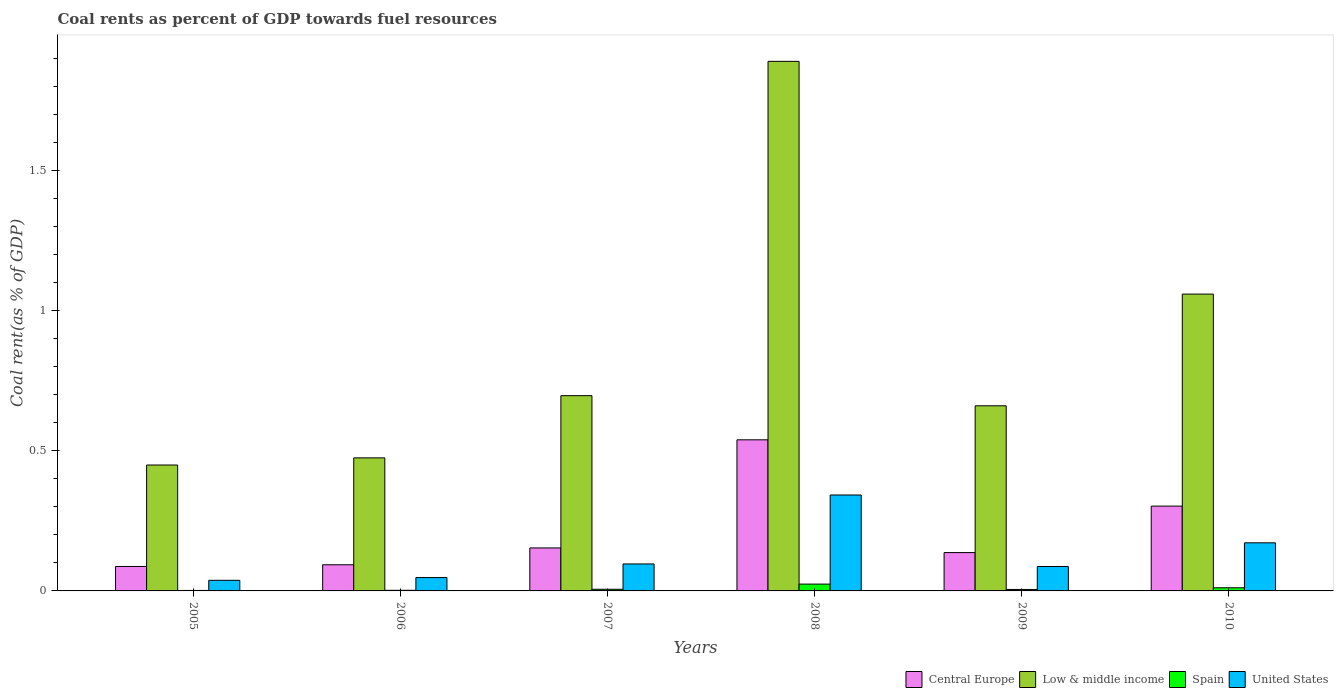How many groups of bars are there?
Keep it short and to the point. 6. Are the number of bars per tick equal to the number of legend labels?
Ensure brevity in your answer.  Yes. Are the number of bars on each tick of the X-axis equal?
Ensure brevity in your answer.  Yes. How many bars are there on the 3rd tick from the left?
Provide a short and direct response. 4. What is the coal rent in United States in 2007?
Provide a succinct answer. 0.1. Across all years, what is the maximum coal rent in United States?
Give a very brief answer. 0.34. Across all years, what is the minimum coal rent in Central Europe?
Your answer should be very brief. 0.09. In which year was the coal rent in Central Europe maximum?
Keep it short and to the point. 2008. What is the total coal rent in United States in the graph?
Provide a succinct answer. 0.78. What is the difference between the coal rent in United States in 2005 and that in 2007?
Keep it short and to the point. -0.06. What is the difference between the coal rent in Central Europe in 2010 and the coal rent in United States in 2005?
Make the answer very short. 0.26. What is the average coal rent in Low & middle income per year?
Make the answer very short. 0.87. In the year 2006, what is the difference between the coal rent in Central Europe and coal rent in Spain?
Provide a short and direct response. 0.09. What is the ratio of the coal rent in United States in 2006 to that in 2009?
Keep it short and to the point. 0.55. What is the difference between the highest and the second highest coal rent in Low & middle income?
Provide a short and direct response. 0.83. What is the difference between the highest and the lowest coal rent in Spain?
Keep it short and to the point. 0.02. In how many years, is the coal rent in Central Europe greater than the average coal rent in Central Europe taken over all years?
Your answer should be compact. 2. Is it the case that in every year, the sum of the coal rent in United States and coal rent in Central Europe is greater than the sum of coal rent in Low & middle income and coal rent in Spain?
Provide a short and direct response. Yes. What does the 2nd bar from the right in 2006 represents?
Your response must be concise. Spain. How many bars are there?
Keep it short and to the point. 24. What is the difference between two consecutive major ticks on the Y-axis?
Your answer should be very brief. 0.5. Are the values on the major ticks of Y-axis written in scientific E-notation?
Provide a short and direct response. No. Where does the legend appear in the graph?
Keep it short and to the point. Bottom right. What is the title of the graph?
Offer a very short reply. Coal rents as percent of GDP towards fuel resources. What is the label or title of the Y-axis?
Your answer should be compact. Coal rent(as % of GDP). What is the Coal rent(as % of GDP) in Central Europe in 2005?
Offer a terse response. 0.09. What is the Coal rent(as % of GDP) of Low & middle income in 2005?
Your response must be concise. 0.45. What is the Coal rent(as % of GDP) in Spain in 2005?
Give a very brief answer. 0. What is the Coal rent(as % of GDP) of United States in 2005?
Offer a terse response. 0.04. What is the Coal rent(as % of GDP) in Central Europe in 2006?
Provide a succinct answer. 0.09. What is the Coal rent(as % of GDP) of Low & middle income in 2006?
Provide a short and direct response. 0.47. What is the Coal rent(as % of GDP) in Spain in 2006?
Make the answer very short. 0. What is the Coal rent(as % of GDP) of United States in 2006?
Your answer should be very brief. 0.05. What is the Coal rent(as % of GDP) in Central Europe in 2007?
Your answer should be compact. 0.15. What is the Coal rent(as % of GDP) of Low & middle income in 2007?
Offer a terse response. 0.7. What is the Coal rent(as % of GDP) in Spain in 2007?
Make the answer very short. 0.01. What is the Coal rent(as % of GDP) in United States in 2007?
Offer a terse response. 0.1. What is the Coal rent(as % of GDP) of Central Europe in 2008?
Your answer should be very brief. 0.54. What is the Coal rent(as % of GDP) of Low & middle income in 2008?
Make the answer very short. 1.89. What is the Coal rent(as % of GDP) of Spain in 2008?
Offer a terse response. 0.02. What is the Coal rent(as % of GDP) of United States in 2008?
Your response must be concise. 0.34. What is the Coal rent(as % of GDP) in Central Europe in 2009?
Your answer should be compact. 0.14. What is the Coal rent(as % of GDP) of Low & middle income in 2009?
Make the answer very short. 0.66. What is the Coal rent(as % of GDP) in Spain in 2009?
Keep it short and to the point. 0.01. What is the Coal rent(as % of GDP) in United States in 2009?
Provide a short and direct response. 0.09. What is the Coal rent(as % of GDP) in Central Europe in 2010?
Make the answer very short. 0.3. What is the Coal rent(as % of GDP) in Low & middle income in 2010?
Your response must be concise. 1.06. What is the Coal rent(as % of GDP) in Spain in 2010?
Provide a succinct answer. 0.01. What is the Coal rent(as % of GDP) in United States in 2010?
Ensure brevity in your answer.  0.17. Across all years, what is the maximum Coal rent(as % of GDP) in Central Europe?
Keep it short and to the point. 0.54. Across all years, what is the maximum Coal rent(as % of GDP) of Low & middle income?
Offer a terse response. 1.89. Across all years, what is the maximum Coal rent(as % of GDP) in Spain?
Keep it short and to the point. 0.02. Across all years, what is the maximum Coal rent(as % of GDP) of United States?
Your answer should be very brief. 0.34. Across all years, what is the minimum Coal rent(as % of GDP) of Central Europe?
Provide a succinct answer. 0.09. Across all years, what is the minimum Coal rent(as % of GDP) of Low & middle income?
Offer a terse response. 0.45. Across all years, what is the minimum Coal rent(as % of GDP) of Spain?
Offer a terse response. 0. Across all years, what is the minimum Coal rent(as % of GDP) in United States?
Offer a terse response. 0.04. What is the total Coal rent(as % of GDP) of Central Europe in the graph?
Your answer should be very brief. 1.31. What is the total Coal rent(as % of GDP) of Low & middle income in the graph?
Ensure brevity in your answer.  5.23. What is the total Coal rent(as % of GDP) of Spain in the graph?
Provide a short and direct response. 0.05. What is the total Coal rent(as % of GDP) of United States in the graph?
Your answer should be very brief. 0.78. What is the difference between the Coal rent(as % of GDP) of Central Europe in 2005 and that in 2006?
Provide a short and direct response. -0.01. What is the difference between the Coal rent(as % of GDP) in Low & middle income in 2005 and that in 2006?
Your response must be concise. -0.03. What is the difference between the Coal rent(as % of GDP) of Spain in 2005 and that in 2006?
Offer a terse response. -0. What is the difference between the Coal rent(as % of GDP) of United States in 2005 and that in 2006?
Your response must be concise. -0.01. What is the difference between the Coal rent(as % of GDP) of Central Europe in 2005 and that in 2007?
Provide a short and direct response. -0.07. What is the difference between the Coal rent(as % of GDP) of Low & middle income in 2005 and that in 2007?
Give a very brief answer. -0.25. What is the difference between the Coal rent(as % of GDP) of Spain in 2005 and that in 2007?
Provide a short and direct response. -0. What is the difference between the Coal rent(as % of GDP) of United States in 2005 and that in 2007?
Provide a succinct answer. -0.06. What is the difference between the Coal rent(as % of GDP) in Central Europe in 2005 and that in 2008?
Provide a short and direct response. -0.45. What is the difference between the Coal rent(as % of GDP) of Low & middle income in 2005 and that in 2008?
Your answer should be very brief. -1.44. What is the difference between the Coal rent(as % of GDP) in Spain in 2005 and that in 2008?
Your answer should be very brief. -0.02. What is the difference between the Coal rent(as % of GDP) in United States in 2005 and that in 2008?
Your answer should be compact. -0.3. What is the difference between the Coal rent(as % of GDP) of Central Europe in 2005 and that in 2009?
Give a very brief answer. -0.05. What is the difference between the Coal rent(as % of GDP) in Low & middle income in 2005 and that in 2009?
Offer a very short reply. -0.21. What is the difference between the Coal rent(as % of GDP) of Spain in 2005 and that in 2009?
Provide a short and direct response. -0. What is the difference between the Coal rent(as % of GDP) in United States in 2005 and that in 2009?
Provide a succinct answer. -0.05. What is the difference between the Coal rent(as % of GDP) of Central Europe in 2005 and that in 2010?
Your response must be concise. -0.22. What is the difference between the Coal rent(as % of GDP) in Low & middle income in 2005 and that in 2010?
Your answer should be very brief. -0.61. What is the difference between the Coal rent(as % of GDP) of Spain in 2005 and that in 2010?
Offer a terse response. -0.01. What is the difference between the Coal rent(as % of GDP) in United States in 2005 and that in 2010?
Keep it short and to the point. -0.13. What is the difference between the Coal rent(as % of GDP) in Central Europe in 2006 and that in 2007?
Provide a succinct answer. -0.06. What is the difference between the Coal rent(as % of GDP) of Low & middle income in 2006 and that in 2007?
Make the answer very short. -0.22. What is the difference between the Coal rent(as % of GDP) in Spain in 2006 and that in 2007?
Your answer should be very brief. -0. What is the difference between the Coal rent(as % of GDP) of United States in 2006 and that in 2007?
Keep it short and to the point. -0.05. What is the difference between the Coal rent(as % of GDP) of Central Europe in 2006 and that in 2008?
Offer a terse response. -0.45. What is the difference between the Coal rent(as % of GDP) in Low & middle income in 2006 and that in 2008?
Your answer should be compact. -1.41. What is the difference between the Coal rent(as % of GDP) of Spain in 2006 and that in 2008?
Ensure brevity in your answer.  -0.02. What is the difference between the Coal rent(as % of GDP) in United States in 2006 and that in 2008?
Make the answer very short. -0.29. What is the difference between the Coal rent(as % of GDP) in Central Europe in 2006 and that in 2009?
Your response must be concise. -0.04. What is the difference between the Coal rent(as % of GDP) of Low & middle income in 2006 and that in 2009?
Your response must be concise. -0.19. What is the difference between the Coal rent(as % of GDP) in Spain in 2006 and that in 2009?
Offer a very short reply. -0. What is the difference between the Coal rent(as % of GDP) of United States in 2006 and that in 2009?
Make the answer very short. -0.04. What is the difference between the Coal rent(as % of GDP) of Central Europe in 2006 and that in 2010?
Your answer should be very brief. -0.21. What is the difference between the Coal rent(as % of GDP) of Low & middle income in 2006 and that in 2010?
Your answer should be compact. -0.58. What is the difference between the Coal rent(as % of GDP) in Spain in 2006 and that in 2010?
Your answer should be very brief. -0.01. What is the difference between the Coal rent(as % of GDP) of United States in 2006 and that in 2010?
Provide a succinct answer. -0.12. What is the difference between the Coal rent(as % of GDP) in Central Europe in 2007 and that in 2008?
Make the answer very short. -0.39. What is the difference between the Coal rent(as % of GDP) of Low & middle income in 2007 and that in 2008?
Give a very brief answer. -1.19. What is the difference between the Coal rent(as % of GDP) of Spain in 2007 and that in 2008?
Provide a short and direct response. -0.02. What is the difference between the Coal rent(as % of GDP) of United States in 2007 and that in 2008?
Ensure brevity in your answer.  -0.25. What is the difference between the Coal rent(as % of GDP) in Central Europe in 2007 and that in 2009?
Your response must be concise. 0.02. What is the difference between the Coal rent(as % of GDP) of Low & middle income in 2007 and that in 2009?
Give a very brief answer. 0.04. What is the difference between the Coal rent(as % of GDP) of Spain in 2007 and that in 2009?
Keep it short and to the point. 0. What is the difference between the Coal rent(as % of GDP) of United States in 2007 and that in 2009?
Keep it short and to the point. 0.01. What is the difference between the Coal rent(as % of GDP) in Central Europe in 2007 and that in 2010?
Make the answer very short. -0.15. What is the difference between the Coal rent(as % of GDP) of Low & middle income in 2007 and that in 2010?
Your response must be concise. -0.36. What is the difference between the Coal rent(as % of GDP) of Spain in 2007 and that in 2010?
Provide a succinct answer. -0.01. What is the difference between the Coal rent(as % of GDP) in United States in 2007 and that in 2010?
Your answer should be compact. -0.08. What is the difference between the Coal rent(as % of GDP) of Central Europe in 2008 and that in 2009?
Offer a terse response. 0.4. What is the difference between the Coal rent(as % of GDP) in Low & middle income in 2008 and that in 2009?
Offer a very short reply. 1.23. What is the difference between the Coal rent(as % of GDP) of Spain in 2008 and that in 2009?
Make the answer very short. 0.02. What is the difference between the Coal rent(as % of GDP) of United States in 2008 and that in 2009?
Give a very brief answer. 0.26. What is the difference between the Coal rent(as % of GDP) of Central Europe in 2008 and that in 2010?
Offer a very short reply. 0.24. What is the difference between the Coal rent(as % of GDP) in Low & middle income in 2008 and that in 2010?
Your response must be concise. 0.83. What is the difference between the Coal rent(as % of GDP) in Spain in 2008 and that in 2010?
Your answer should be compact. 0.01. What is the difference between the Coal rent(as % of GDP) in United States in 2008 and that in 2010?
Give a very brief answer. 0.17. What is the difference between the Coal rent(as % of GDP) of Central Europe in 2009 and that in 2010?
Offer a terse response. -0.17. What is the difference between the Coal rent(as % of GDP) of Low & middle income in 2009 and that in 2010?
Provide a short and direct response. -0.4. What is the difference between the Coal rent(as % of GDP) in Spain in 2009 and that in 2010?
Ensure brevity in your answer.  -0.01. What is the difference between the Coal rent(as % of GDP) in United States in 2009 and that in 2010?
Offer a terse response. -0.08. What is the difference between the Coal rent(as % of GDP) in Central Europe in 2005 and the Coal rent(as % of GDP) in Low & middle income in 2006?
Offer a terse response. -0.39. What is the difference between the Coal rent(as % of GDP) in Central Europe in 2005 and the Coal rent(as % of GDP) in Spain in 2006?
Provide a succinct answer. 0.09. What is the difference between the Coal rent(as % of GDP) of Central Europe in 2005 and the Coal rent(as % of GDP) of United States in 2006?
Offer a terse response. 0.04. What is the difference between the Coal rent(as % of GDP) in Low & middle income in 2005 and the Coal rent(as % of GDP) in Spain in 2006?
Your response must be concise. 0.45. What is the difference between the Coal rent(as % of GDP) in Low & middle income in 2005 and the Coal rent(as % of GDP) in United States in 2006?
Offer a very short reply. 0.4. What is the difference between the Coal rent(as % of GDP) of Spain in 2005 and the Coal rent(as % of GDP) of United States in 2006?
Provide a succinct answer. -0.05. What is the difference between the Coal rent(as % of GDP) of Central Europe in 2005 and the Coal rent(as % of GDP) of Low & middle income in 2007?
Your response must be concise. -0.61. What is the difference between the Coal rent(as % of GDP) in Central Europe in 2005 and the Coal rent(as % of GDP) in Spain in 2007?
Make the answer very short. 0.08. What is the difference between the Coal rent(as % of GDP) in Central Europe in 2005 and the Coal rent(as % of GDP) in United States in 2007?
Your answer should be very brief. -0.01. What is the difference between the Coal rent(as % of GDP) in Low & middle income in 2005 and the Coal rent(as % of GDP) in Spain in 2007?
Provide a short and direct response. 0.44. What is the difference between the Coal rent(as % of GDP) in Low & middle income in 2005 and the Coal rent(as % of GDP) in United States in 2007?
Offer a terse response. 0.35. What is the difference between the Coal rent(as % of GDP) in Spain in 2005 and the Coal rent(as % of GDP) in United States in 2007?
Give a very brief answer. -0.09. What is the difference between the Coal rent(as % of GDP) of Central Europe in 2005 and the Coal rent(as % of GDP) of Low & middle income in 2008?
Offer a very short reply. -1.8. What is the difference between the Coal rent(as % of GDP) of Central Europe in 2005 and the Coal rent(as % of GDP) of Spain in 2008?
Ensure brevity in your answer.  0.06. What is the difference between the Coal rent(as % of GDP) of Central Europe in 2005 and the Coal rent(as % of GDP) of United States in 2008?
Make the answer very short. -0.25. What is the difference between the Coal rent(as % of GDP) in Low & middle income in 2005 and the Coal rent(as % of GDP) in Spain in 2008?
Ensure brevity in your answer.  0.42. What is the difference between the Coal rent(as % of GDP) in Low & middle income in 2005 and the Coal rent(as % of GDP) in United States in 2008?
Give a very brief answer. 0.11. What is the difference between the Coal rent(as % of GDP) in Spain in 2005 and the Coal rent(as % of GDP) in United States in 2008?
Offer a very short reply. -0.34. What is the difference between the Coal rent(as % of GDP) of Central Europe in 2005 and the Coal rent(as % of GDP) of Low & middle income in 2009?
Your answer should be very brief. -0.57. What is the difference between the Coal rent(as % of GDP) of Central Europe in 2005 and the Coal rent(as % of GDP) of Spain in 2009?
Keep it short and to the point. 0.08. What is the difference between the Coal rent(as % of GDP) of Central Europe in 2005 and the Coal rent(as % of GDP) of United States in 2009?
Your answer should be compact. 0. What is the difference between the Coal rent(as % of GDP) of Low & middle income in 2005 and the Coal rent(as % of GDP) of Spain in 2009?
Your answer should be compact. 0.44. What is the difference between the Coal rent(as % of GDP) of Low & middle income in 2005 and the Coal rent(as % of GDP) of United States in 2009?
Keep it short and to the point. 0.36. What is the difference between the Coal rent(as % of GDP) of Spain in 2005 and the Coal rent(as % of GDP) of United States in 2009?
Give a very brief answer. -0.09. What is the difference between the Coal rent(as % of GDP) of Central Europe in 2005 and the Coal rent(as % of GDP) of Low & middle income in 2010?
Your answer should be very brief. -0.97. What is the difference between the Coal rent(as % of GDP) in Central Europe in 2005 and the Coal rent(as % of GDP) in Spain in 2010?
Provide a succinct answer. 0.08. What is the difference between the Coal rent(as % of GDP) in Central Europe in 2005 and the Coal rent(as % of GDP) in United States in 2010?
Offer a terse response. -0.08. What is the difference between the Coal rent(as % of GDP) in Low & middle income in 2005 and the Coal rent(as % of GDP) in Spain in 2010?
Your answer should be very brief. 0.44. What is the difference between the Coal rent(as % of GDP) in Low & middle income in 2005 and the Coal rent(as % of GDP) in United States in 2010?
Your answer should be compact. 0.28. What is the difference between the Coal rent(as % of GDP) of Spain in 2005 and the Coal rent(as % of GDP) of United States in 2010?
Give a very brief answer. -0.17. What is the difference between the Coal rent(as % of GDP) in Central Europe in 2006 and the Coal rent(as % of GDP) in Low & middle income in 2007?
Your answer should be compact. -0.6. What is the difference between the Coal rent(as % of GDP) in Central Europe in 2006 and the Coal rent(as % of GDP) in Spain in 2007?
Offer a terse response. 0.09. What is the difference between the Coal rent(as % of GDP) in Central Europe in 2006 and the Coal rent(as % of GDP) in United States in 2007?
Your answer should be compact. -0. What is the difference between the Coal rent(as % of GDP) in Low & middle income in 2006 and the Coal rent(as % of GDP) in Spain in 2007?
Provide a succinct answer. 0.47. What is the difference between the Coal rent(as % of GDP) of Low & middle income in 2006 and the Coal rent(as % of GDP) of United States in 2007?
Offer a very short reply. 0.38. What is the difference between the Coal rent(as % of GDP) in Spain in 2006 and the Coal rent(as % of GDP) in United States in 2007?
Ensure brevity in your answer.  -0.09. What is the difference between the Coal rent(as % of GDP) in Central Europe in 2006 and the Coal rent(as % of GDP) in Low & middle income in 2008?
Provide a short and direct response. -1.8. What is the difference between the Coal rent(as % of GDP) of Central Europe in 2006 and the Coal rent(as % of GDP) of Spain in 2008?
Your response must be concise. 0.07. What is the difference between the Coal rent(as % of GDP) of Central Europe in 2006 and the Coal rent(as % of GDP) of United States in 2008?
Offer a very short reply. -0.25. What is the difference between the Coal rent(as % of GDP) in Low & middle income in 2006 and the Coal rent(as % of GDP) in Spain in 2008?
Keep it short and to the point. 0.45. What is the difference between the Coal rent(as % of GDP) in Low & middle income in 2006 and the Coal rent(as % of GDP) in United States in 2008?
Ensure brevity in your answer.  0.13. What is the difference between the Coal rent(as % of GDP) of Spain in 2006 and the Coal rent(as % of GDP) of United States in 2008?
Offer a terse response. -0.34. What is the difference between the Coal rent(as % of GDP) of Central Europe in 2006 and the Coal rent(as % of GDP) of Low & middle income in 2009?
Give a very brief answer. -0.57. What is the difference between the Coal rent(as % of GDP) of Central Europe in 2006 and the Coal rent(as % of GDP) of Spain in 2009?
Make the answer very short. 0.09. What is the difference between the Coal rent(as % of GDP) of Central Europe in 2006 and the Coal rent(as % of GDP) of United States in 2009?
Provide a short and direct response. 0.01. What is the difference between the Coal rent(as % of GDP) in Low & middle income in 2006 and the Coal rent(as % of GDP) in Spain in 2009?
Keep it short and to the point. 0.47. What is the difference between the Coal rent(as % of GDP) in Low & middle income in 2006 and the Coal rent(as % of GDP) in United States in 2009?
Ensure brevity in your answer.  0.39. What is the difference between the Coal rent(as % of GDP) of Spain in 2006 and the Coal rent(as % of GDP) of United States in 2009?
Keep it short and to the point. -0.08. What is the difference between the Coal rent(as % of GDP) of Central Europe in 2006 and the Coal rent(as % of GDP) of Low & middle income in 2010?
Ensure brevity in your answer.  -0.97. What is the difference between the Coal rent(as % of GDP) of Central Europe in 2006 and the Coal rent(as % of GDP) of Spain in 2010?
Offer a terse response. 0.08. What is the difference between the Coal rent(as % of GDP) in Central Europe in 2006 and the Coal rent(as % of GDP) in United States in 2010?
Keep it short and to the point. -0.08. What is the difference between the Coal rent(as % of GDP) of Low & middle income in 2006 and the Coal rent(as % of GDP) of Spain in 2010?
Your response must be concise. 0.46. What is the difference between the Coal rent(as % of GDP) in Low & middle income in 2006 and the Coal rent(as % of GDP) in United States in 2010?
Make the answer very short. 0.3. What is the difference between the Coal rent(as % of GDP) in Spain in 2006 and the Coal rent(as % of GDP) in United States in 2010?
Make the answer very short. -0.17. What is the difference between the Coal rent(as % of GDP) in Central Europe in 2007 and the Coal rent(as % of GDP) in Low & middle income in 2008?
Provide a succinct answer. -1.74. What is the difference between the Coal rent(as % of GDP) in Central Europe in 2007 and the Coal rent(as % of GDP) in Spain in 2008?
Keep it short and to the point. 0.13. What is the difference between the Coal rent(as % of GDP) in Central Europe in 2007 and the Coal rent(as % of GDP) in United States in 2008?
Your answer should be compact. -0.19. What is the difference between the Coal rent(as % of GDP) of Low & middle income in 2007 and the Coal rent(as % of GDP) of Spain in 2008?
Ensure brevity in your answer.  0.67. What is the difference between the Coal rent(as % of GDP) of Low & middle income in 2007 and the Coal rent(as % of GDP) of United States in 2008?
Provide a short and direct response. 0.35. What is the difference between the Coal rent(as % of GDP) of Spain in 2007 and the Coal rent(as % of GDP) of United States in 2008?
Keep it short and to the point. -0.34. What is the difference between the Coal rent(as % of GDP) of Central Europe in 2007 and the Coal rent(as % of GDP) of Low & middle income in 2009?
Keep it short and to the point. -0.51. What is the difference between the Coal rent(as % of GDP) of Central Europe in 2007 and the Coal rent(as % of GDP) of Spain in 2009?
Offer a terse response. 0.15. What is the difference between the Coal rent(as % of GDP) in Central Europe in 2007 and the Coal rent(as % of GDP) in United States in 2009?
Your answer should be compact. 0.07. What is the difference between the Coal rent(as % of GDP) in Low & middle income in 2007 and the Coal rent(as % of GDP) in Spain in 2009?
Your response must be concise. 0.69. What is the difference between the Coal rent(as % of GDP) of Low & middle income in 2007 and the Coal rent(as % of GDP) of United States in 2009?
Make the answer very short. 0.61. What is the difference between the Coal rent(as % of GDP) in Spain in 2007 and the Coal rent(as % of GDP) in United States in 2009?
Keep it short and to the point. -0.08. What is the difference between the Coal rent(as % of GDP) of Central Europe in 2007 and the Coal rent(as % of GDP) of Low & middle income in 2010?
Provide a succinct answer. -0.91. What is the difference between the Coal rent(as % of GDP) of Central Europe in 2007 and the Coal rent(as % of GDP) of Spain in 2010?
Your response must be concise. 0.14. What is the difference between the Coal rent(as % of GDP) of Central Europe in 2007 and the Coal rent(as % of GDP) of United States in 2010?
Provide a succinct answer. -0.02. What is the difference between the Coal rent(as % of GDP) of Low & middle income in 2007 and the Coal rent(as % of GDP) of Spain in 2010?
Ensure brevity in your answer.  0.69. What is the difference between the Coal rent(as % of GDP) of Low & middle income in 2007 and the Coal rent(as % of GDP) of United States in 2010?
Offer a terse response. 0.52. What is the difference between the Coal rent(as % of GDP) in Spain in 2007 and the Coal rent(as % of GDP) in United States in 2010?
Keep it short and to the point. -0.17. What is the difference between the Coal rent(as % of GDP) in Central Europe in 2008 and the Coal rent(as % of GDP) in Low & middle income in 2009?
Offer a terse response. -0.12. What is the difference between the Coal rent(as % of GDP) in Central Europe in 2008 and the Coal rent(as % of GDP) in Spain in 2009?
Your answer should be very brief. 0.53. What is the difference between the Coal rent(as % of GDP) of Central Europe in 2008 and the Coal rent(as % of GDP) of United States in 2009?
Your answer should be very brief. 0.45. What is the difference between the Coal rent(as % of GDP) of Low & middle income in 2008 and the Coal rent(as % of GDP) of Spain in 2009?
Make the answer very short. 1.88. What is the difference between the Coal rent(as % of GDP) of Low & middle income in 2008 and the Coal rent(as % of GDP) of United States in 2009?
Provide a short and direct response. 1.8. What is the difference between the Coal rent(as % of GDP) in Spain in 2008 and the Coal rent(as % of GDP) in United States in 2009?
Your answer should be compact. -0.06. What is the difference between the Coal rent(as % of GDP) of Central Europe in 2008 and the Coal rent(as % of GDP) of Low & middle income in 2010?
Your answer should be very brief. -0.52. What is the difference between the Coal rent(as % of GDP) of Central Europe in 2008 and the Coal rent(as % of GDP) of Spain in 2010?
Offer a terse response. 0.53. What is the difference between the Coal rent(as % of GDP) in Central Europe in 2008 and the Coal rent(as % of GDP) in United States in 2010?
Provide a succinct answer. 0.37. What is the difference between the Coal rent(as % of GDP) of Low & middle income in 2008 and the Coal rent(as % of GDP) of Spain in 2010?
Ensure brevity in your answer.  1.88. What is the difference between the Coal rent(as % of GDP) of Low & middle income in 2008 and the Coal rent(as % of GDP) of United States in 2010?
Offer a very short reply. 1.72. What is the difference between the Coal rent(as % of GDP) of Spain in 2008 and the Coal rent(as % of GDP) of United States in 2010?
Your answer should be very brief. -0.15. What is the difference between the Coal rent(as % of GDP) of Central Europe in 2009 and the Coal rent(as % of GDP) of Low & middle income in 2010?
Provide a succinct answer. -0.92. What is the difference between the Coal rent(as % of GDP) of Central Europe in 2009 and the Coal rent(as % of GDP) of Spain in 2010?
Make the answer very short. 0.13. What is the difference between the Coal rent(as % of GDP) of Central Europe in 2009 and the Coal rent(as % of GDP) of United States in 2010?
Your answer should be compact. -0.03. What is the difference between the Coal rent(as % of GDP) of Low & middle income in 2009 and the Coal rent(as % of GDP) of Spain in 2010?
Give a very brief answer. 0.65. What is the difference between the Coal rent(as % of GDP) of Low & middle income in 2009 and the Coal rent(as % of GDP) of United States in 2010?
Give a very brief answer. 0.49. What is the difference between the Coal rent(as % of GDP) of Spain in 2009 and the Coal rent(as % of GDP) of United States in 2010?
Your response must be concise. -0.17. What is the average Coal rent(as % of GDP) in Central Europe per year?
Provide a short and direct response. 0.22. What is the average Coal rent(as % of GDP) in Low & middle income per year?
Your answer should be very brief. 0.87. What is the average Coal rent(as % of GDP) in Spain per year?
Your answer should be very brief. 0.01. What is the average Coal rent(as % of GDP) of United States per year?
Ensure brevity in your answer.  0.13. In the year 2005, what is the difference between the Coal rent(as % of GDP) in Central Europe and Coal rent(as % of GDP) in Low & middle income?
Keep it short and to the point. -0.36. In the year 2005, what is the difference between the Coal rent(as % of GDP) of Central Europe and Coal rent(as % of GDP) of Spain?
Make the answer very short. 0.09. In the year 2005, what is the difference between the Coal rent(as % of GDP) in Central Europe and Coal rent(as % of GDP) in United States?
Provide a succinct answer. 0.05. In the year 2005, what is the difference between the Coal rent(as % of GDP) of Low & middle income and Coal rent(as % of GDP) of Spain?
Keep it short and to the point. 0.45. In the year 2005, what is the difference between the Coal rent(as % of GDP) of Low & middle income and Coal rent(as % of GDP) of United States?
Offer a terse response. 0.41. In the year 2005, what is the difference between the Coal rent(as % of GDP) in Spain and Coal rent(as % of GDP) in United States?
Ensure brevity in your answer.  -0.04. In the year 2006, what is the difference between the Coal rent(as % of GDP) of Central Europe and Coal rent(as % of GDP) of Low & middle income?
Provide a short and direct response. -0.38. In the year 2006, what is the difference between the Coal rent(as % of GDP) in Central Europe and Coal rent(as % of GDP) in Spain?
Ensure brevity in your answer.  0.09. In the year 2006, what is the difference between the Coal rent(as % of GDP) in Central Europe and Coal rent(as % of GDP) in United States?
Ensure brevity in your answer.  0.05. In the year 2006, what is the difference between the Coal rent(as % of GDP) in Low & middle income and Coal rent(as % of GDP) in Spain?
Make the answer very short. 0.47. In the year 2006, what is the difference between the Coal rent(as % of GDP) of Low & middle income and Coal rent(as % of GDP) of United States?
Give a very brief answer. 0.43. In the year 2006, what is the difference between the Coal rent(as % of GDP) of Spain and Coal rent(as % of GDP) of United States?
Ensure brevity in your answer.  -0.05. In the year 2007, what is the difference between the Coal rent(as % of GDP) of Central Europe and Coal rent(as % of GDP) of Low & middle income?
Your response must be concise. -0.54. In the year 2007, what is the difference between the Coal rent(as % of GDP) of Central Europe and Coal rent(as % of GDP) of Spain?
Ensure brevity in your answer.  0.15. In the year 2007, what is the difference between the Coal rent(as % of GDP) in Central Europe and Coal rent(as % of GDP) in United States?
Keep it short and to the point. 0.06. In the year 2007, what is the difference between the Coal rent(as % of GDP) of Low & middle income and Coal rent(as % of GDP) of Spain?
Offer a very short reply. 0.69. In the year 2007, what is the difference between the Coal rent(as % of GDP) in Low & middle income and Coal rent(as % of GDP) in United States?
Offer a terse response. 0.6. In the year 2007, what is the difference between the Coal rent(as % of GDP) of Spain and Coal rent(as % of GDP) of United States?
Give a very brief answer. -0.09. In the year 2008, what is the difference between the Coal rent(as % of GDP) of Central Europe and Coal rent(as % of GDP) of Low & middle income?
Make the answer very short. -1.35. In the year 2008, what is the difference between the Coal rent(as % of GDP) in Central Europe and Coal rent(as % of GDP) in Spain?
Provide a succinct answer. 0.51. In the year 2008, what is the difference between the Coal rent(as % of GDP) of Central Europe and Coal rent(as % of GDP) of United States?
Give a very brief answer. 0.2. In the year 2008, what is the difference between the Coal rent(as % of GDP) in Low & middle income and Coal rent(as % of GDP) in Spain?
Ensure brevity in your answer.  1.86. In the year 2008, what is the difference between the Coal rent(as % of GDP) of Low & middle income and Coal rent(as % of GDP) of United States?
Your answer should be very brief. 1.55. In the year 2008, what is the difference between the Coal rent(as % of GDP) of Spain and Coal rent(as % of GDP) of United States?
Your answer should be compact. -0.32. In the year 2009, what is the difference between the Coal rent(as % of GDP) of Central Europe and Coal rent(as % of GDP) of Low & middle income?
Provide a short and direct response. -0.52. In the year 2009, what is the difference between the Coal rent(as % of GDP) of Central Europe and Coal rent(as % of GDP) of Spain?
Offer a very short reply. 0.13. In the year 2009, what is the difference between the Coal rent(as % of GDP) of Central Europe and Coal rent(as % of GDP) of United States?
Your response must be concise. 0.05. In the year 2009, what is the difference between the Coal rent(as % of GDP) in Low & middle income and Coal rent(as % of GDP) in Spain?
Make the answer very short. 0.66. In the year 2009, what is the difference between the Coal rent(as % of GDP) of Low & middle income and Coal rent(as % of GDP) of United States?
Your response must be concise. 0.57. In the year 2009, what is the difference between the Coal rent(as % of GDP) in Spain and Coal rent(as % of GDP) in United States?
Keep it short and to the point. -0.08. In the year 2010, what is the difference between the Coal rent(as % of GDP) in Central Europe and Coal rent(as % of GDP) in Low & middle income?
Your answer should be compact. -0.76. In the year 2010, what is the difference between the Coal rent(as % of GDP) of Central Europe and Coal rent(as % of GDP) of Spain?
Keep it short and to the point. 0.29. In the year 2010, what is the difference between the Coal rent(as % of GDP) of Central Europe and Coal rent(as % of GDP) of United States?
Your response must be concise. 0.13. In the year 2010, what is the difference between the Coal rent(as % of GDP) of Low & middle income and Coal rent(as % of GDP) of Spain?
Offer a very short reply. 1.05. In the year 2010, what is the difference between the Coal rent(as % of GDP) in Low & middle income and Coal rent(as % of GDP) in United States?
Your response must be concise. 0.89. In the year 2010, what is the difference between the Coal rent(as % of GDP) in Spain and Coal rent(as % of GDP) in United States?
Provide a succinct answer. -0.16. What is the ratio of the Coal rent(as % of GDP) of Central Europe in 2005 to that in 2006?
Provide a short and direct response. 0.94. What is the ratio of the Coal rent(as % of GDP) of Low & middle income in 2005 to that in 2006?
Offer a very short reply. 0.95. What is the ratio of the Coal rent(as % of GDP) of Spain in 2005 to that in 2006?
Provide a short and direct response. 0.76. What is the ratio of the Coal rent(as % of GDP) in United States in 2005 to that in 2006?
Provide a short and direct response. 0.8. What is the ratio of the Coal rent(as % of GDP) in Central Europe in 2005 to that in 2007?
Offer a very short reply. 0.57. What is the ratio of the Coal rent(as % of GDP) of Low & middle income in 2005 to that in 2007?
Keep it short and to the point. 0.64. What is the ratio of the Coal rent(as % of GDP) in Spain in 2005 to that in 2007?
Provide a short and direct response. 0.28. What is the ratio of the Coal rent(as % of GDP) of United States in 2005 to that in 2007?
Ensure brevity in your answer.  0.39. What is the ratio of the Coal rent(as % of GDP) in Central Europe in 2005 to that in 2008?
Your answer should be compact. 0.16. What is the ratio of the Coal rent(as % of GDP) in Low & middle income in 2005 to that in 2008?
Keep it short and to the point. 0.24. What is the ratio of the Coal rent(as % of GDP) of Spain in 2005 to that in 2008?
Ensure brevity in your answer.  0.07. What is the ratio of the Coal rent(as % of GDP) of United States in 2005 to that in 2008?
Your response must be concise. 0.11. What is the ratio of the Coal rent(as % of GDP) of Central Europe in 2005 to that in 2009?
Your answer should be compact. 0.64. What is the ratio of the Coal rent(as % of GDP) in Low & middle income in 2005 to that in 2009?
Your response must be concise. 0.68. What is the ratio of the Coal rent(as % of GDP) in Spain in 2005 to that in 2009?
Your response must be concise. 0.32. What is the ratio of the Coal rent(as % of GDP) in United States in 2005 to that in 2009?
Offer a very short reply. 0.43. What is the ratio of the Coal rent(as % of GDP) in Central Europe in 2005 to that in 2010?
Provide a short and direct response. 0.29. What is the ratio of the Coal rent(as % of GDP) in Low & middle income in 2005 to that in 2010?
Offer a terse response. 0.42. What is the ratio of the Coal rent(as % of GDP) in Spain in 2005 to that in 2010?
Your response must be concise. 0.15. What is the ratio of the Coal rent(as % of GDP) of United States in 2005 to that in 2010?
Your response must be concise. 0.22. What is the ratio of the Coal rent(as % of GDP) of Central Europe in 2006 to that in 2007?
Make the answer very short. 0.61. What is the ratio of the Coal rent(as % of GDP) of Low & middle income in 2006 to that in 2007?
Provide a short and direct response. 0.68. What is the ratio of the Coal rent(as % of GDP) in Spain in 2006 to that in 2007?
Give a very brief answer. 0.37. What is the ratio of the Coal rent(as % of GDP) of United States in 2006 to that in 2007?
Provide a short and direct response. 0.49. What is the ratio of the Coal rent(as % of GDP) in Central Europe in 2006 to that in 2008?
Ensure brevity in your answer.  0.17. What is the ratio of the Coal rent(as % of GDP) of Low & middle income in 2006 to that in 2008?
Offer a terse response. 0.25. What is the ratio of the Coal rent(as % of GDP) of Spain in 2006 to that in 2008?
Provide a succinct answer. 0.09. What is the ratio of the Coal rent(as % of GDP) in United States in 2006 to that in 2008?
Offer a terse response. 0.14. What is the ratio of the Coal rent(as % of GDP) in Central Europe in 2006 to that in 2009?
Your answer should be compact. 0.68. What is the ratio of the Coal rent(as % of GDP) of Low & middle income in 2006 to that in 2009?
Provide a succinct answer. 0.72. What is the ratio of the Coal rent(as % of GDP) of Spain in 2006 to that in 2009?
Give a very brief answer. 0.42. What is the ratio of the Coal rent(as % of GDP) of United States in 2006 to that in 2009?
Offer a very short reply. 0.55. What is the ratio of the Coal rent(as % of GDP) in Central Europe in 2006 to that in 2010?
Keep it short and to the point. 0.31. What is the ratio of the Coal rent(as % of GDP) in Low & middle income in 2006 to that in 2010?
Provide a succinct answer. 0.45. What is the ratio of the Coal rent(as % of GDP) in Spain in 2006 to that in 2010?
Your response must be concise. 0.2. What is the ratio of the Coal rent(as % of GDP) in United States in 2006 to that in 2010?
Offer a very short reply. 0.28. What is the ratio of the Coal rent(as % of GDP) in Central Europe in 2007 to that in 2008?
Keep it short and to the point. 0.28. What is the ratio of the Coal rent(as % of GDP) in Low & middle income in 2007 to that in 2008?
Provide a succinct answer. 0.37. What is the ratio of the Coal rent(as % of GDP) in Spain in 2007 to that in 2008?
Your response must be concise. 0.24. What is the ratio of the Coal rent(as % of GDP) of United States in 2007 to that in 2008?
Your answer should be very brief. 0.28. What is the ratio of the Coal rent(as % of GDP) in Central Europe in 2007 to that in 2009?
Make the answer very short. 1.12. What is the ratio of the Coal rent(as % of GDP) in Low & middle income in 2007 to that in 2009?
Keep it short and to the point. 1.05. What is the ratio of the Coal rent(as % of GDP) of Spain in 2007 to that in 2009?
Make the answer very short. 1.14. What is the ratio of the Coal rent(as % of GDP) of United States in 2007 to that in 2009?
Your answer should be very brief. 1.1. What is the ratio of the Coal rent(as % of GDP) of Central Europe in 2007 to that in 2010?
Make the answer very short. 0.51. What is the ratio of the Coal rent(as % of GDP) in Low & middle income in 2007 to that in 2010?
Provide a succinct answer. 0.66. What is the ratio of the Coal rent(as % of GDP) in Spain in 2007 to that in 2010?
Your response must be concise. 0.53. What is the ratio of the Coal rent(as % of GDP) of United States in 2007 to that in 2010?
Keep it short and to the point. 0.56. What is the ratio of the Coal rent(as % of GDP) in Central Europe in 2008 to that in 2009?
Give a very brief answer. 3.94. What is the ratio of the Coal rent(as % of GDP) in Low & middle income in 2008 to that in 2009?
Your response must be concise. 2.86. What is the ratio of the Coal rent(as % of GDP) in Spain in 2008 to that in 2009?
Your answer should be compact. 4.67. What is the ratio of the Coal rent(as % of GDP) of United States in 2008 to that in 2009?
Ensure brevity in your answer.  3.93. What is the ratio of the Coal rent(as % of GDP) in Central Europe in 2008 to that in 2010?
Provide a succinct answer. 1.78. What is the ratio of the Coal rent(as % of GDP) of Low & middle income in 2008 to that in 2010?
Your answer should be very brief. 1.78. What is the ratio of the Coal rent(as % of GDP) of Spain in 2008 to that in 2010?
Your response must be concise. 2.16. What is the ratio of the Coal rent(as % of GDP) in United States in 2008 to that in 2010?
Provide a succinct answer. 1.99. What is the ratio of the Coal rent(as % of GDP) in Central Europe in 2009 to that in 2010?
Offer a terse response. 0.45. What is the ratio of the Coal rent(as % of GDP) in Low & middle income in 2009 to that in 2010?
Keep it short and to the point. 0.62. What is the ratio of the Coal rent(as % of GDP) in Spain in 2009 to that in 2010?
Ensure brevity in your answer.  0.46. What is the ratio of the Coal rent(as % of GDP) of United States in 2009 to that in 2010?
Your answer should be compact. 0.51. What is the difference between the highest and the second highest Coal rent(as % of GDP) in Central Europe?
Keep it short and to the point. 0.24. What is the difference between the highest and the second highest Coal rent(as % of GDP) of Low & middle income?
Provide a short and direct response. 0.83. What is the difference between the highest and the second highest Coal rent(as % of GDP) of Spain?
Your answer should be very brief. 0.01. What is the difference between the highest and the second highest Coal rent(as % of GDP) in United States?
Provide a succinct answer. 0.17. What is the difference between the highest and the lowest Coal rent(as % of GDP) in Central Europe?
Give a very brief answer. 0.45. What is the difference between the highest and the lowest Coal rent(as % of GDP) in Low & middle income?
Ensure brevity in your answer.  1.44. What is the difference between the highest and the lowest Coal rent(as % of GDP) in Spain?
Keep it short and to the point. 0.02. What is the difference between the highest and the lowest Coal rent(as % of GDP) of United States?
Offer a very short reply. 0.3. 